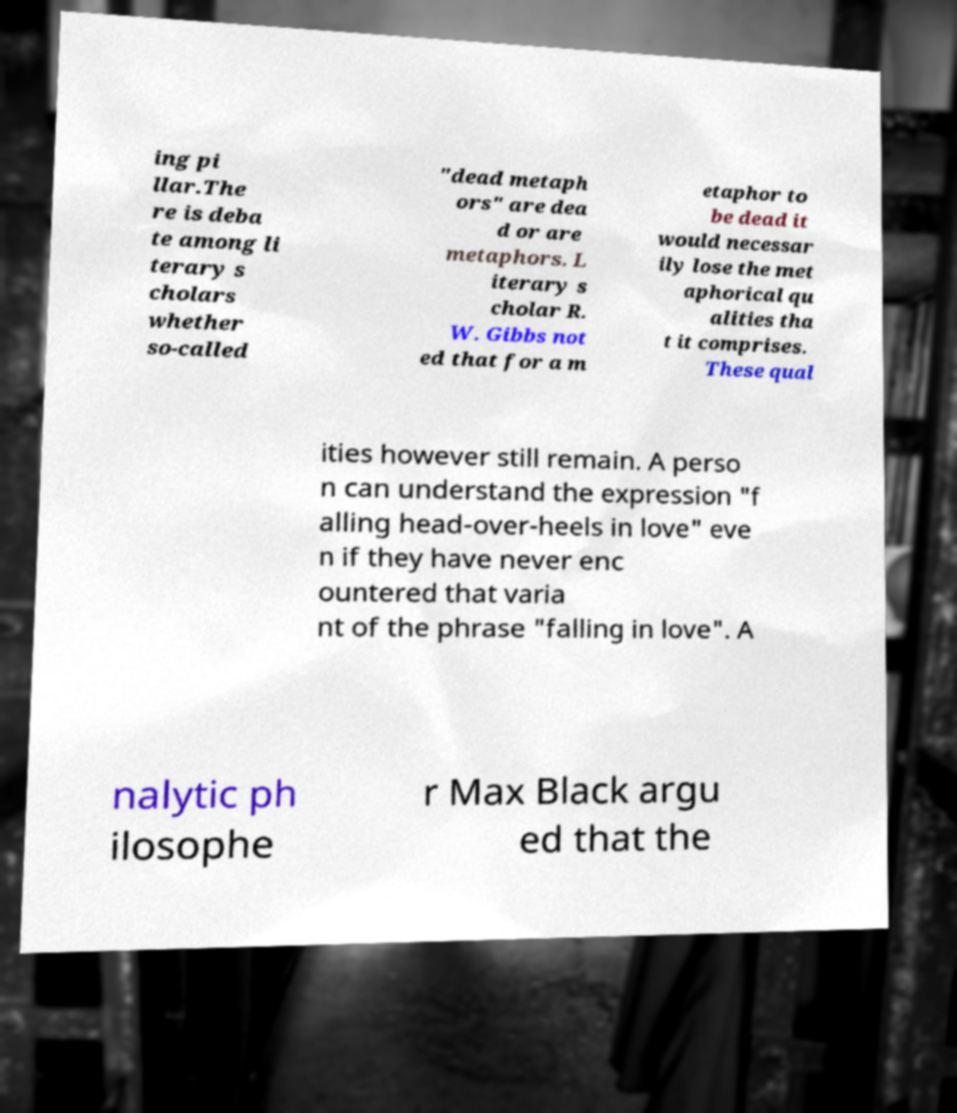For documentation purposes, I need the text within this image transcribed. Could you provide that? ing pi llar.The re is deba te among li terary s cholars whether so-called "dead metaph ors" are dea d or are metaphors. L iterary s cholar R. W. Gibbs not ed that for a m etaphor to be dead it would necessar ily lose the met aphorical qu alities tha t it comprises. These qual ities however still remain. A perso n can understand the expression "f alling head-over-heels in love" eve n if they have never enc ountered that varia nt of the phrase "falling in love". A nalytic ph ilosophe r Max Black argu ed that the 